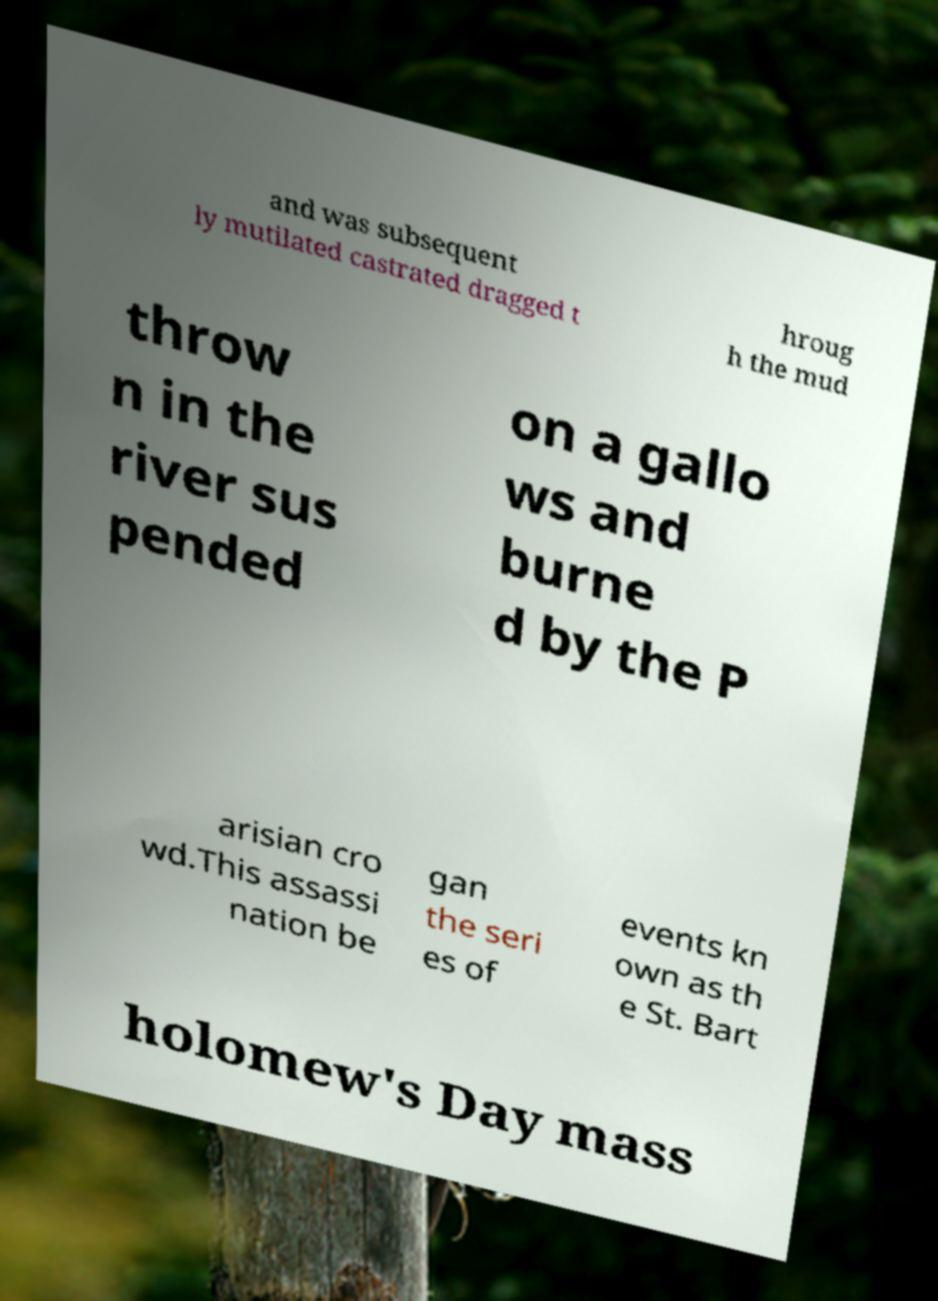Please identify and transcribe the text found in this image. and was subsequent ly mutilated castrated dragged t hroug h the mud throw n in the river sus pended on a gallo ws and burne d by the P arisian cro wd.This assassi nation be gan the seri es of events kn own as th e St. Bart holomew's Day mass 